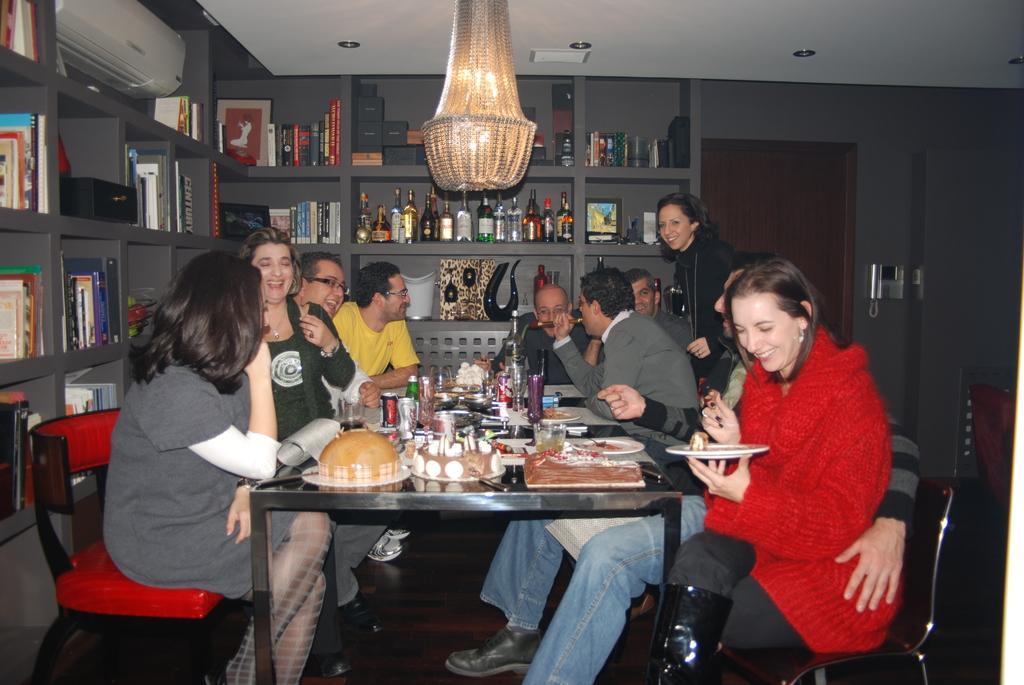How would you summarize this image in a sentence or two? In this picture we can find a group of people sitting on chairs near the table. On the table we can find some food items, with drinks, bottles, glasses, plates, in background we can find a shelf in shelf we can find a bottles, books, things, and just beside to racks we can find door, wall, and the ceiling we find a lights. 